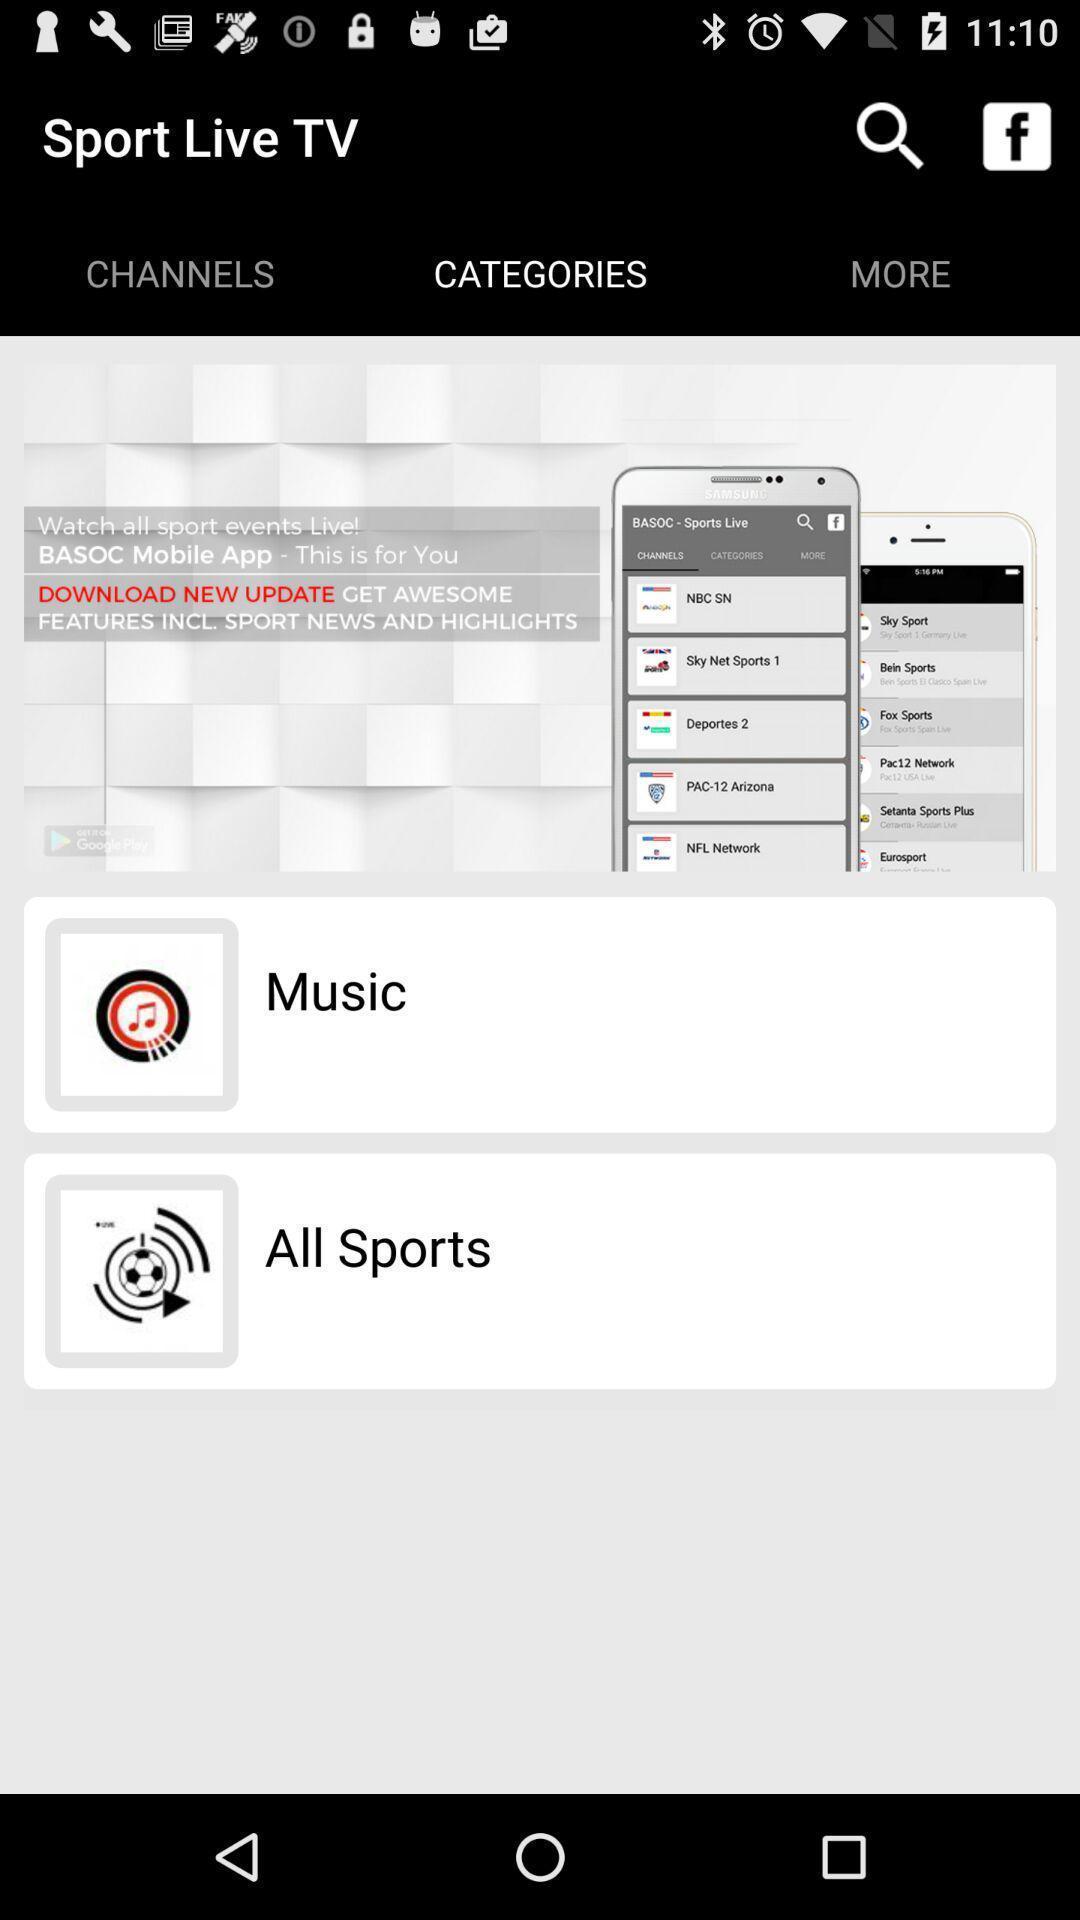Explain the elements present in this screenshot. Search page with different options in the live streaming app. 